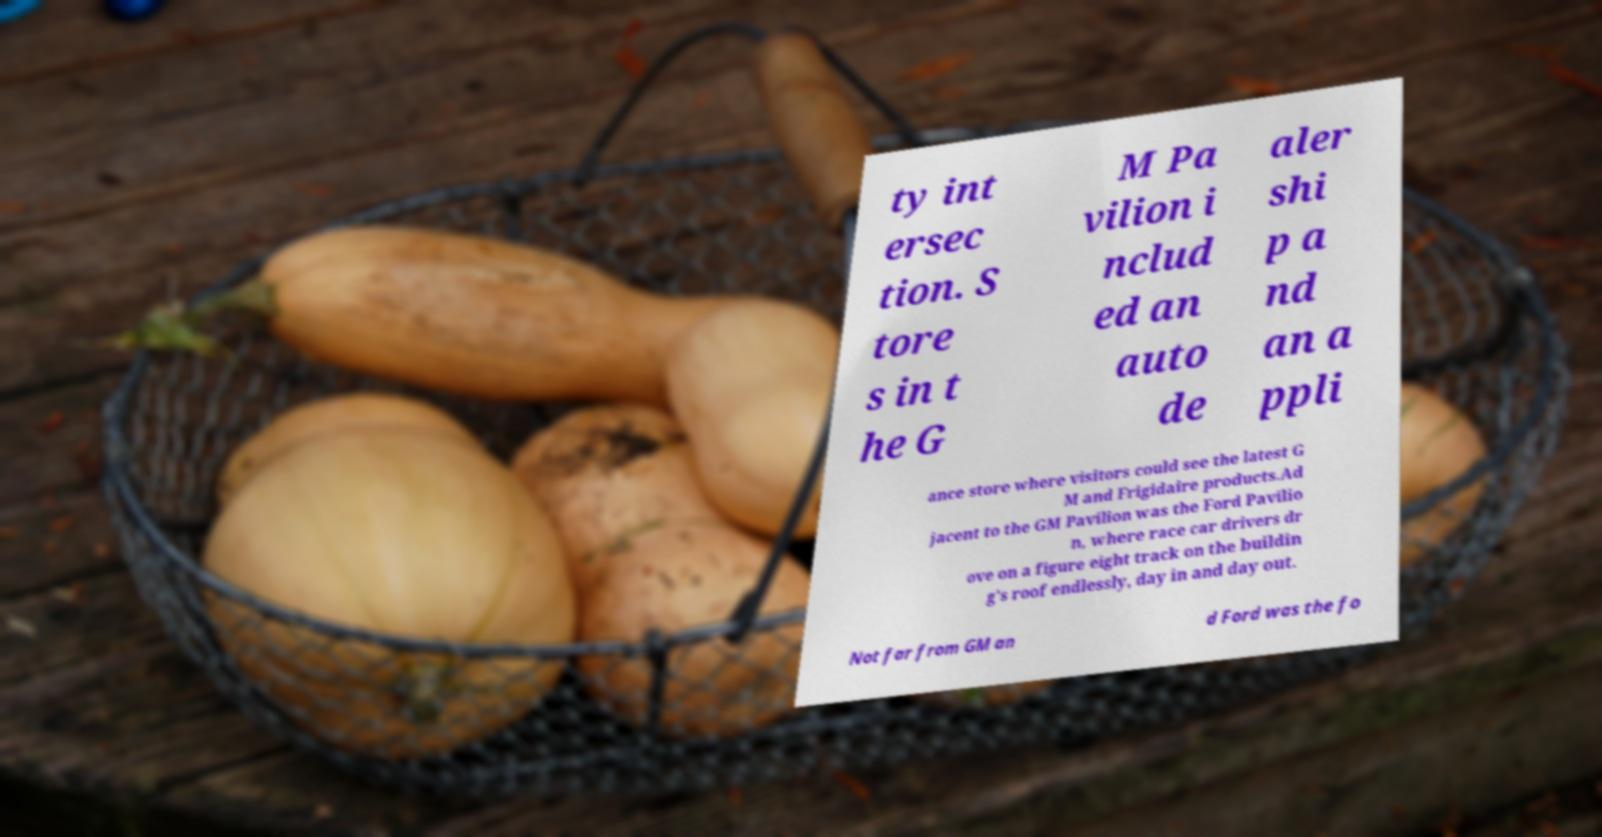There's text embedded in this image that I need extracted. Can you transcribe it verbatim? ty int ersec tion. S tore s in t he G M Pa vilion i nclud ed an auto de aler shi p a nd an a ppli ance store where visitors could see the latest G M and Frigidaire products.Ad jacent to the GM Pavilion was the Ford Pavilio n, where race car drivers dr ove on a figure eight track on the buildin g's roof endlessly, day in and day out. Not far from GM an d Ford was the fo 